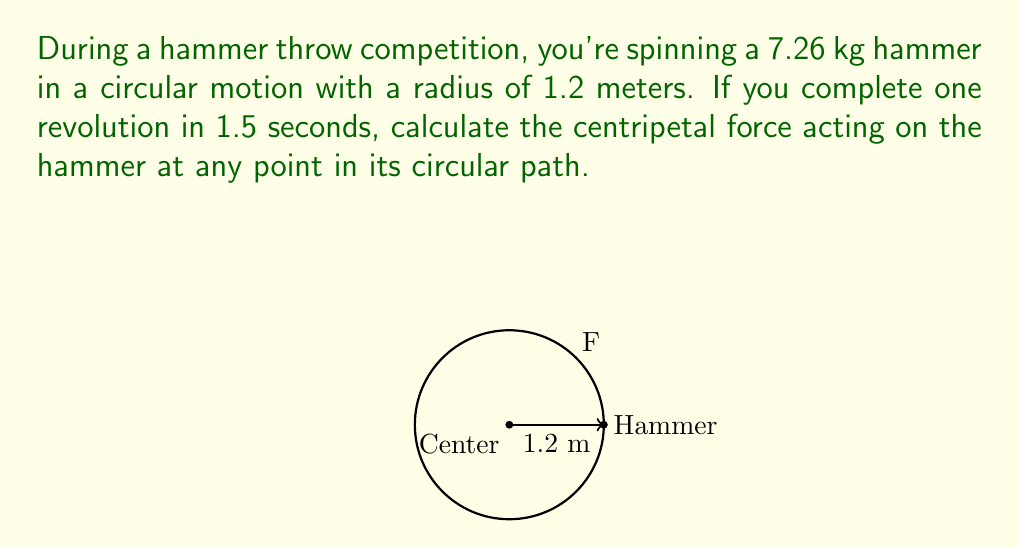Show me your answer to this math problem. Let's approach this step-by-step:

1) First, we need to calculate the angular velocity $\omega$. Given that one revolution takes 1.5 seconds:

   $$\omega = \frac{2\pi}{T} = \frac{2\pi}{1.5} \approx 4.19 \text{ rad/s}$$

2) Now, we can use the formula for centripetal acceleration:

   $$a_c = \omega^2 r$$

   where $r$ is the radius of the circular path.

3) Substituting the values:

   $$a_c = (4.19)^2 \cdot 1.2 \approx 21.06 \text{ m/s}^2$$

4) The centripetal force is given by Newton's Second Law:

   $$F_c = ma_c$$

   where $m$ is the mass of the hammer.

5) Substituting the values:

   $$F_c = 7.26 \cdot 21.06 \approx 152.90 \text{ N}$$

Therefore, the centripetal force acting on the hammer is approximately 152.90 Newtons.
Answer: $152.90 \text{ N}$ 